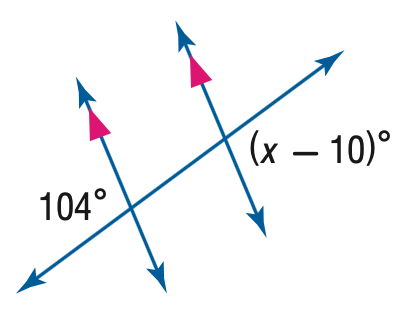Question: Find the value of the variable x in the figure.
Choices:
A. 86
B. 94
C. 96
D. 114
Answer with the letter. Answer: D 